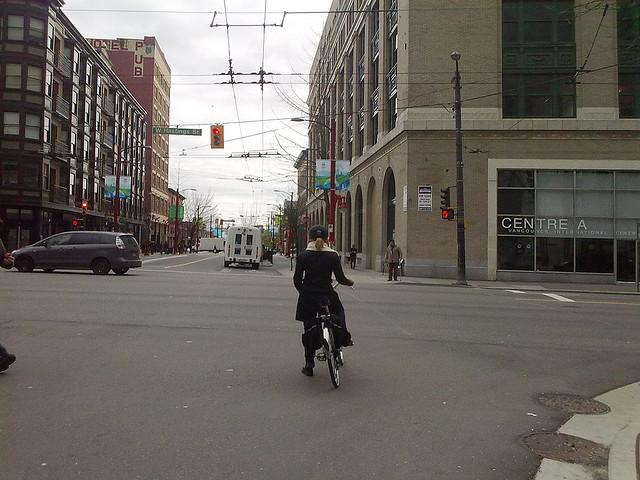What province is she riding in?

Choices:
A) manitoba
B) alberta
C) british columbia
D) ontario british columbia 